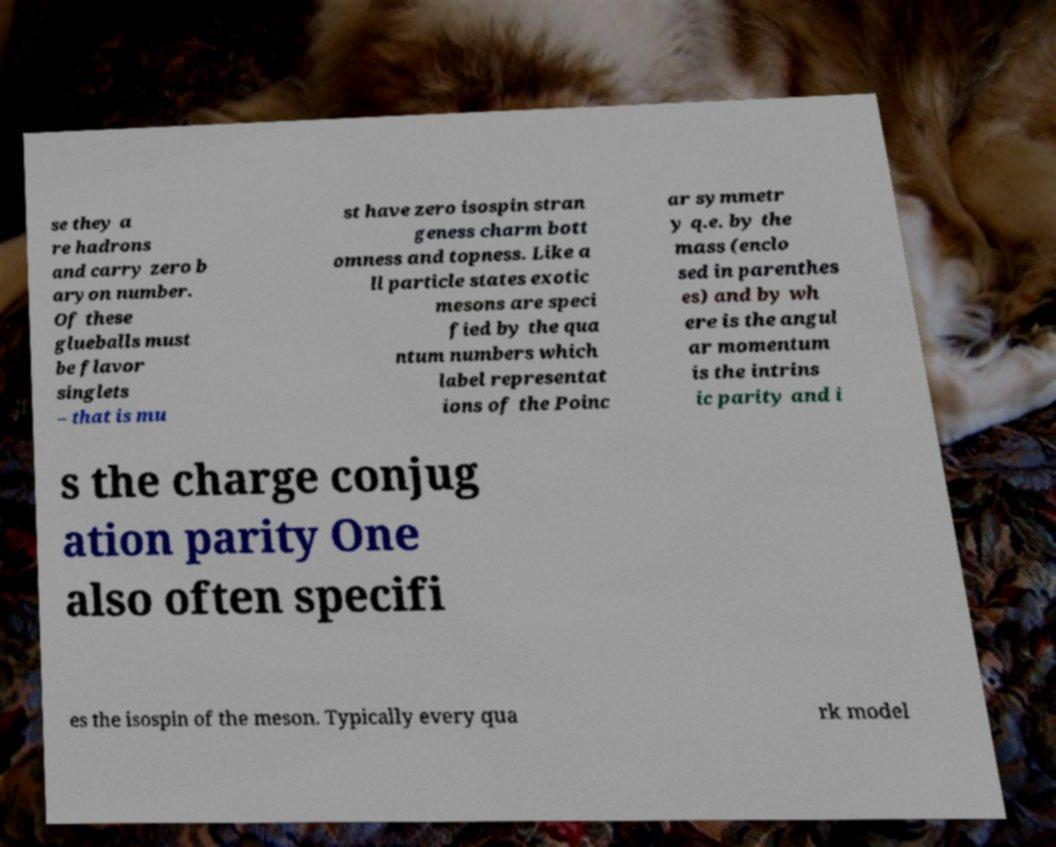For documentation purposes, I need the text within this image transcribed. Could you provide that? se they a re hadrons and carry zero b aryon number. Of these glueballs must be flavor singlets – that is mu st have zero isospin stran geness charm bott omness and topness. Like a ll particle states exotic mesons are speci fied by the qua ntum numbers which label representat ions of the Poinc ar symmetr y q.e. by the mass (enclo sed in parenthes es) and by wh ere is the angul ar momentum is the intrins ic parity and i s the charge conjug ation parity One also often specifi es the isospin of the meson. Typically every qua rk model 